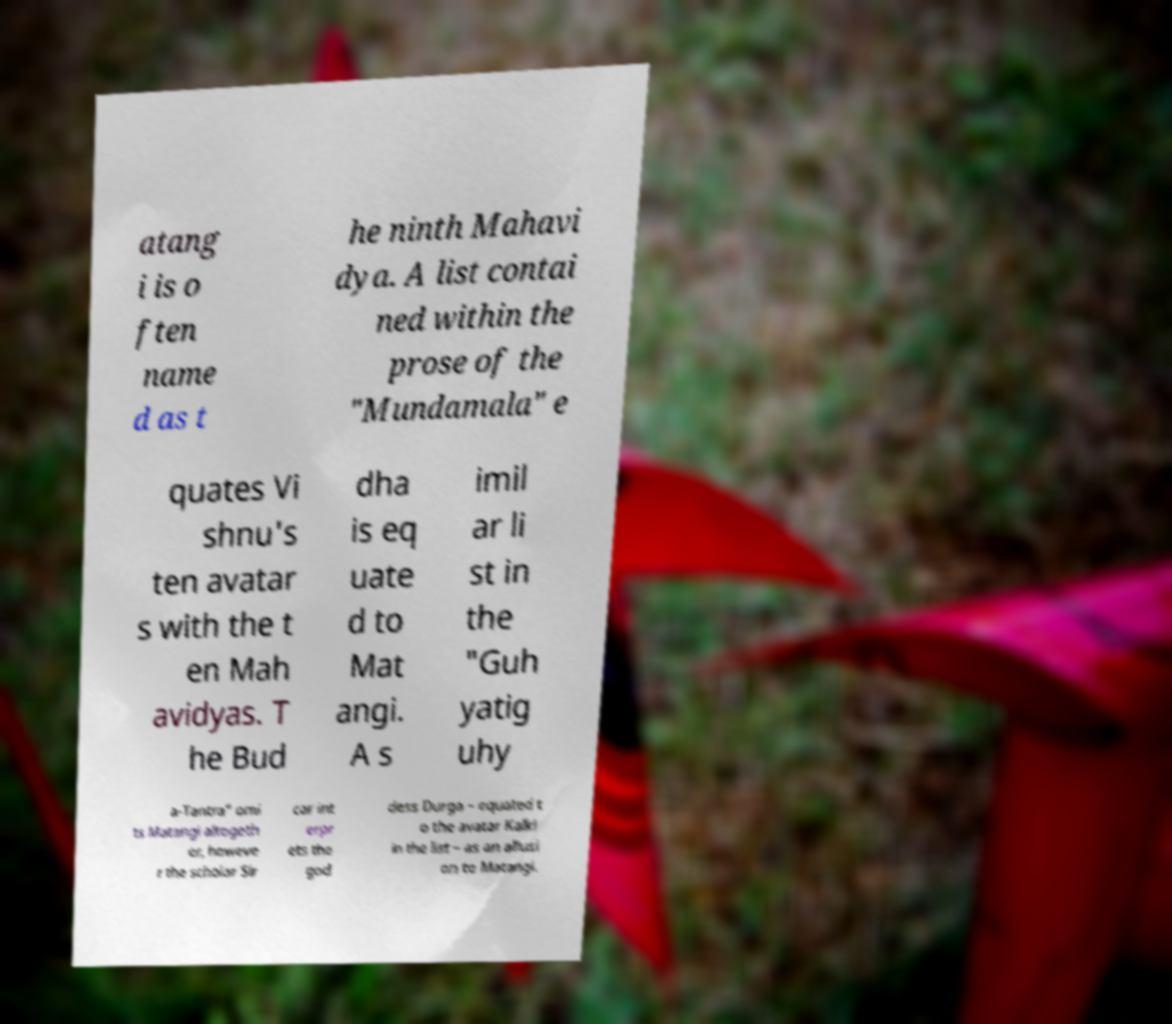Please read and relay the text visible in this image. What does it say? atang i is o ften name d as t he ninth Mahavi dya. A list contai ned within the prose of the "Mundamala" e quates Vi shnu's ten avatar s with the t en Mah avidyas. T he Bud dha is eq uate d to Mat angi. A s imil ar li st in the "Guh yatig uhy a-Tantra" omi ts Matangi altogeth er, howeve r the scholar Sir car int erpr ets the god dess Durga – equated t o the avatar Kalki in the list – as an allusi on to Matangi. 